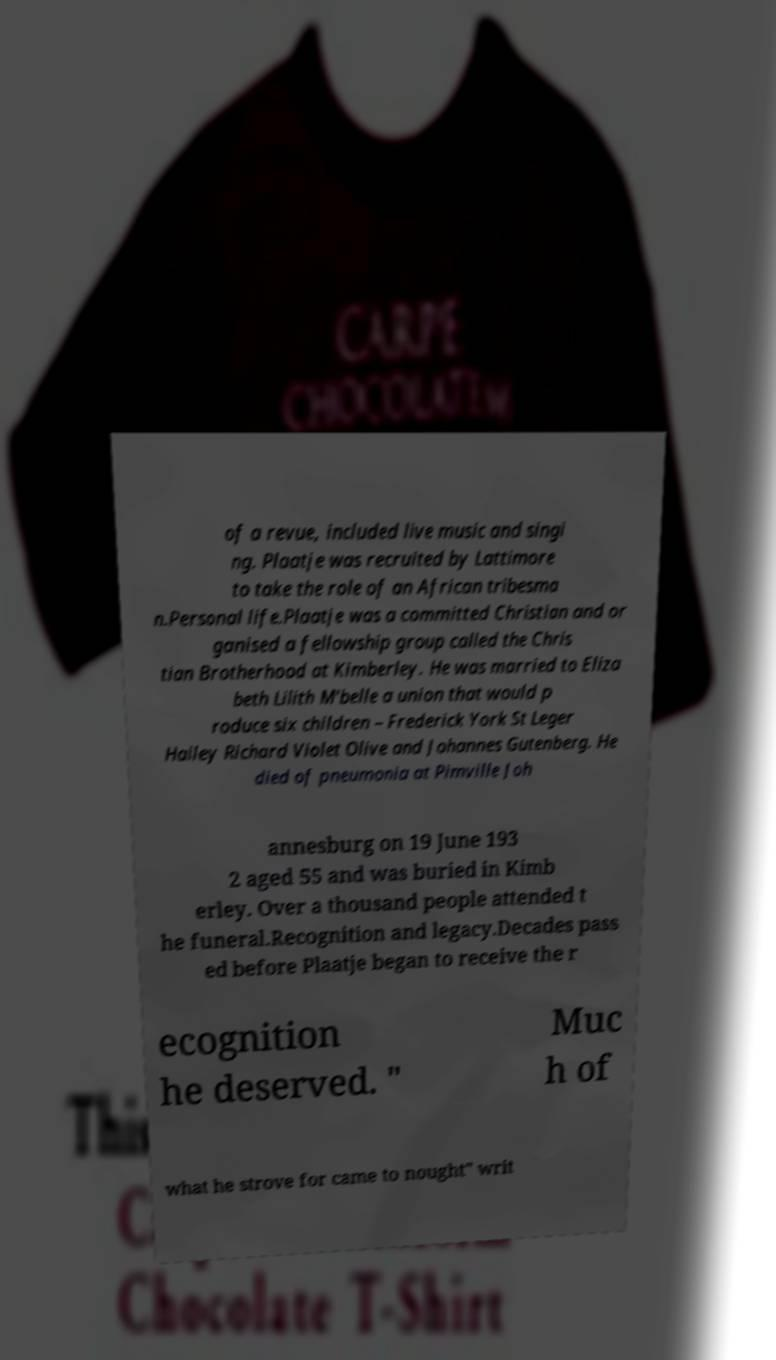Could you extract and type out the text from this image? of a revue, included live music and singi ng. Plaatje was recruited by Lattimore to take the role of an African tribesma n.Personal life.Plaatje was a committed Christian and or ganised a fellowship group called the Chris tian Brotherhood at Kimberley. He was married to Eliza beth Lilith M'belle a union that would p roduce six children – Frederick York St Leger Halley Richard Violet Olive and Johannes Gutenberg. He died of pneumonia at Pimville Joh annesburg on 19 June 193 2 aged 55 and was buried in Kimb erley. Over a thousand people attended t he funeral.Recognition and legacy.Decades pass ed before Plaatje began to receive the r ecognition he deserved. " Muc h of what he strove for came to nought" writ 